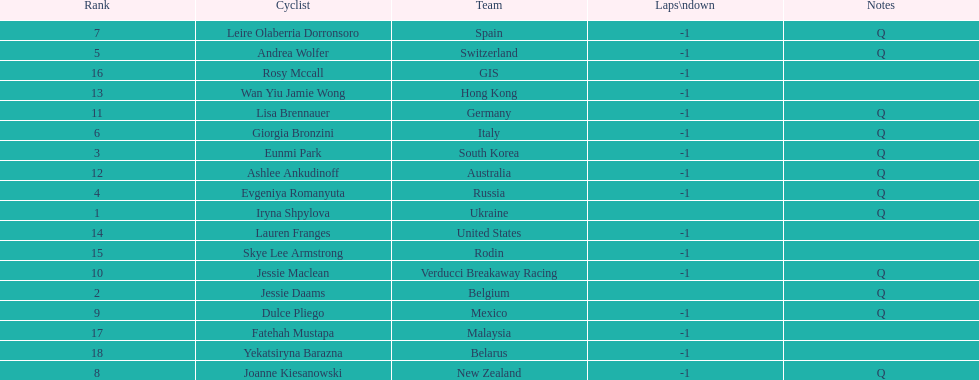How many cyclist do not have -1 laps down? 2. 